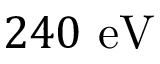Convert formula to latex. <formula><loc_0><loc_0><loc_500><loc_500>2 4 0 e V</formula> 